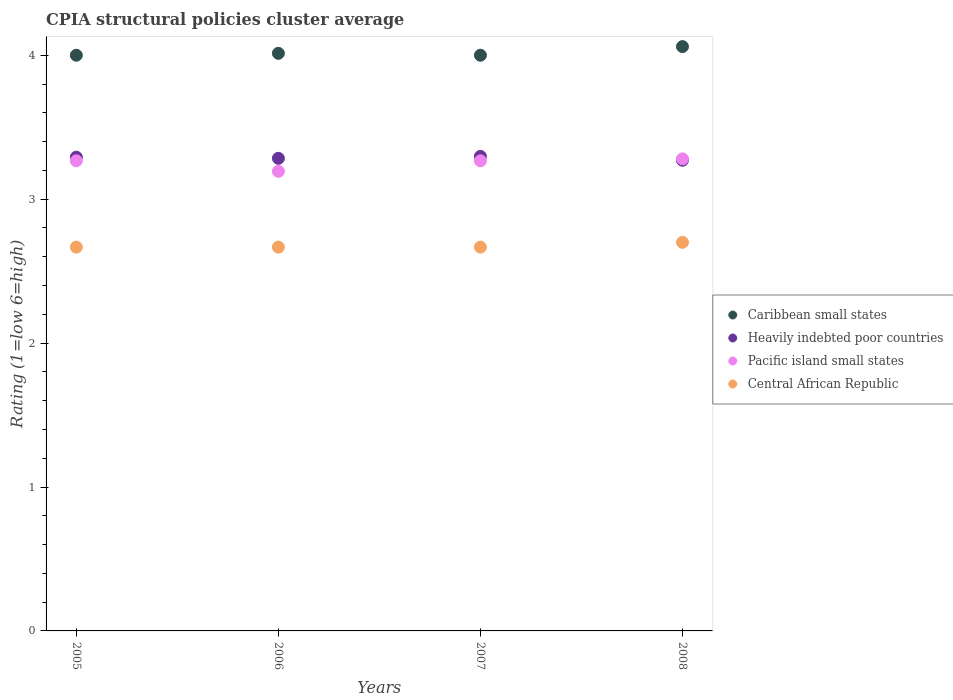How many different coloured dotlines are there?
Give a very brief answer. 4. What is the CPIA rating in Caribbean small states in 2008?
Provide a short and direct response. 4.06. Across all years, what is the maximum CPIA rating in Pacific island small states?
Make the answer very short. 3.28. Across all years, what is the minimum CPIA rating in Central African Republic?
Offer a terse response. 2.67. In which year was the CPIA rating in Central African Republic minimum?
Offer a very short reply. 2005. What is the total CPIA rating in Heavily indebted poor countries in the graph?
Your response must be concise. 13.14. What is the difference between the CPIA rating in Pacific island small states in 2006 and that in 2007?
Provide a short and direct response. -0.07. What is the difference between the CPIA rating in Heavily indebted poor countries in 2006 and the CPIA rating in Caribbean small states in 2008?
Offer a very short reply. -0.78. What is the average CPIA rating in Caribbean small states per year?
Offer a very short reply. 4.02. In the year 2005, what is the difference between the CPIA rating in Caribbean small states and CPIA rating in Pacific island small states?
Provide a succinct answer. 0.73. What is the ratio of the CPIA rating in Heavily indebted poor countries in 2006 to that in 2007?
Provide a short and direct response. 1. Is the difference between the CPIA rating in Caribbean small states in 2007 and 2008 greater than the difference between the CPIA rating in Pacific island small states in 2007 and 2008?
Ensure brevity in your answer.  No. What is the difference between the highest and the second highest CPIA rating in Central African Republic?
Keep it short and to the point. 0.03. What is the difference between the highest and the lowest CPIA rating in Heavily indebted poor countries?
Your response must be concise. 0.03. Is the CPIA rating in Central African Republic strictly greater than the CPIA rating in Heavily indebted poor countries over the years?
Keep it short and to the point. No. Is the CPIA rating in Heavily indebted poor countries strictly less than the CPIA rating in Central African Republic over the years?
Offer a very short reply. No. What is the difference between two consecutive major ticks on the Y-axis?
Offer a very short reply. 1. Does the graph contain any zero values?
Your answer should be compact. No. Does the graph contain grids?
Provide a short and direct response. No. How many legend labels are there?
Offer a terse response. 4. How are the legend labels stacked?
Provide a short and direct response. Vertical. What is the title of the graph?
Make the answer very short. CPIA structural policies cluster average. Does "Bulgaria" appear as one of the legend labels in the graph?
Give a very brief answer. No. What is the label or title of the X-axis?
Make the answer very short. Years. What is the label or title of the Y-axis?
Keep it short and to the point. Rating (1=low 6=high). What is the Rating (1=low 6=high) of Caribbean small states in 2005?
Ensure brevity in your answer.  4. What is the Rating (1=low 6=high) of Heavily indebted poor countries in 2005?
Keep it short and to the point. 3.29. What is the Rating (1=low 6=high) of Pacific island small states in 2005?
Keep it short and to the point. 3.27. What is the Rating (1=low 6=high) in Central African Republic in 2005?
Keep it short and to the point. 2.67. What is the Rating (1=low 6=high) of Caribbean small states in 2006?
Make the answer very short. 4.01. What is the Rating (1=low 6=high) in Heavily indebted poor countries in 2006?
Your response must be concise. 3.28. What is the Rating (1=low 6=high) in Pacific island small states in 2006?
Your response must be concise. 3.19. What is the Rating (1=low 6=high) of Central African Republic in 2006?
Your response must be concise. 2.67. What is the Rating (1=low 6=high) in Heavily indebted poor countries in 2007?
Keep it short and to the point. 3.3. What is the Rating (1=low 6=high) in Pacific island small states in 2007?
Your response must be concise. 3.27. What is the Rating (1=low 6=high) in Central African Republic in 2007?
Keep it short and to the point. 2.67. What is the Rating (1=low 6=high) in Caribbean small states in 2008?
Your response must be concise. 4.06. What is the Rating (1=low 6=high) of Heavily indebted poor countries in 2008?
Make the answer very short. 3.27. What is the Rating (1=low 6=high) in Pacific island small states in 2008?
Provide a short and direct response. 3.28. Across all years, what is the maximum Rating (1=low 6=high) of Caribbean small states?
Offer a terse response. 4.06. Across all years, what is the maximum Rating (1=low 6=high) of Heavily indebted poor countries?
Provide a succinct answer. 3.3. Across all years, what is the maximum Rating (1=low 6=high) in Pacific island small states?
Provide a succinct answer. 3.28. Across all years, what is the maximum Rating (1=low 6=high) in Central African Republic?
Keep it short and to the point. 2.7. Across all years, what is the minimum Rating (1=low 6=high) of Caribbean small states?
Offer a very short reply. 4. Across all years, what is the minimum Rating (1=low 6=high) of Heavily indebted poor countries?
Your response must be concise. 3.27. Across all years, what is the minimum Rating (1=low 6=high) of Pacific island small states?
Offer a terse response. 3.19. Across all years, what is the minimum Rating (1=low 6=high) in Central African Republic?
Provide a short and direct response. 2.67. What is the total Rating (1=low 6=high) of Caribbean small states in the graph?
Provide a succinct answer. 16.07. What is the total Rating (1=low 6=high) of Heavily indebted poor countries in the graph?
Make the answer very short. 13.14. What is the total Rating (1=low 6=high) of Pacific island small states in the graph?
Provide a succinct answer. 13.01. What is the total Rating (1=low 6=high) of Central African Republic in the graph?
Your response must be concise. 10.7. What is the difference between the Rating (1=low 6=high) in Caribbean small states in 2005 and that in 2006?
Keep it short and to the point. -0.01. What is the difference between the Rating (1=low 6=high) of Heavily indebted poor countries in 2005 and that in 2006?
Offer a very short reply. 0.01. What is the difference between the Rating (1=low 6=high) of Pacific island small states in 2005 and that in 2006?
Give a very brief answer. 0.07. What is the difference between the Rating (1=low 6=high) of Central African Republic in 2005 and that in 2006?
Ensure brevity in your answer.  0. What is the difference between the Rating (1=low 6=high) in Caribbean small states in 2005 and that in 2007?
Make the answer very short. 0. What is the difference between the Rating (1=low 6=high) of Heavily indebted poor countries in 2005 and that in 2007?
Give a very brief answer. -0.01. What is the difference between the Rating (1=low 6=high) of Pacific island small states in 2005 and that in 2007?
Make the answer very short. 0. What is the difference between the Rating (1=low 6=high) of Caribbean small states in 2005 and that in 2008?
Ensure brevity in your answer.  -0.06. What is the difference between the Rating (1=low 6=high) in Heavily indebted poor countries in 2005 and that in 2008?
Your answer should be very brief. 0.02. What is the difference between the Rating (1=low 6=high) of Pacific island small states in 2005 and that in 2008?
Give a very brief answer. -0.01. What is the difference between the Rating (1=low 6=high) of Central African Republic in 2005 and that in 2008?
Provide a short and direct response. -0.03. What is the difference between the Rating (1=low 6=high) in Caribbean small states in 2006 and that in 2007?
Provide a short and direct response. 0.01. What is the difference between the Rating (1=low 6=high) of Heavily indebted poor countries in 2006 and that in 2007?
Your response must be concise. -0.01. What is the difference between the Rating (1=low 6=high) in Pacific island small states in 2006 and that in 2007?
Your response must be concise. -0.07. What is the difference between the Rating (1=low 6=high) of Central African Republic in 2006 and that in 2007?
Make the answer very short. 0. What is the difference between the Rating (1=low 6=high) in Caribbean small states in 2006 and that in 2008?
Your response must be concise. -0.05. What is the difference between the Rating (1=low 6=high) in Heavily indebted poor countries in 2006 and that in 2008?
Offer a very short reply. 0.01. What is the difference between the Rating (1=low 6=high) of Pacific island small states in 2006 and that in 2008?
Your answer should be compact. -0.09. What is the difference between the Rating (1=low 6=high) of Central African Republic in 2006 and that in 2008?
Provide a succinct answer. -0.03. What is the difference between the Rating (1=low 6=high) of Caribbean small states in 2007 and that in 2008?
Give a very brief answer. -0.06. What is the difference between the Rating (1=low 6=high) of Heavily indebted poor countries in 2007 and that in 2008?
Keep it short and to the point. 0.03. What is the difference between the Rating (1=low 6=high) of Pacific island small states in 2007 and that in 2008?
Provide a short and direct response. -0.01. What is the difference between the Rating (1=low 6=high) in Central African Republic in 2007 and that in 2008?
Your answer should be very brief. -0.03. What is the difference between the Rating (1=low 6=high) of Caribbean small states in 2005 and the Rating (1=low 6=high) of Heavily indebted poor countries in 2006?
Your response must be concise. 0.72. What is the difference between the Rating (1=low 6=high) of Caribbean small states in 2005 and the Rating (1=low 6=high) of Pacific island small states in 2006?
Offer a very short reply. 0.81. What is the difference between the Rating (1=low 6=high) in Caribbean small states in 2005 and the Rating (1=low 6=high) in Central African Republic in 2006?
Offer a terse response. 1.33. What is the difference between the Rating (1=low 6=high) in Heavily indebted poor countries in 2005 and the Rating (1=low 6=high) in Pacific island small states in 2006?
Your response must be concise. 0.1. What is the difference between the Rating (1=low 6=high) in Caribbean small states in 2005 and the Rating (1=low 6=high) in Heavily indebted poor countries in 2007?
Offer a very short reply. 0.7. What is the difference between the Rating (1=low 6=high) in Caribbean small states in 2005 and the Rating (1=low 6=high) in Pacific island small states in 2007?
Make the answer very short. 0.73. What is the difference between the Rating (1=low 6=high) of Caribbean small states in 2005 and the Rating (1=low 6=high) of Central African Republic in 2007?
Offer a very short reply. 1.33. What is the difference between the Rating (1=low 6=high) of Heavily indebted poor countries in 2005 and the Rating (1=low 6=high) of Pacific island small states in 2007?
Your response must be concise. 0.03. What is the difference between the Rating (1=low 6=high) of Heavily indebted poor countries in 2005 and the Rating (1=low 6=high) of Central African Republic in 2007?
Your answer should be compact. 0.62. What is the difference between the Rating (1=low 6=high) in Pacific island small states in 2005 and the Rating (1=low 6=high) in Central African Republic in 2007?
Your answer should be very brief. 0.6. What is the difference between the Rating (1=low 6=high) of Caribbean small states in 2005 and the Rating (1=low 6=high) of Heavily indebted poor countries in 2008?
Offer a very short reply. 0.73. What is the difference between the Rating (1=low 6=high) of Caribbean small states in 2005 and the Rating (1=low 6=high) of Pacific island small states in 2008?
Your answer should be compact. 0.72. What is the difference between the Rating (1=low 6=high) of Caribbean small states in 2005 and the Rating (1=low 6=high) of Central African Republic in 2008?
Make the answer very short. 1.3. What is the difference between the Rating (1=low 6=high) in Heavily indebted poor countries in 2005 and the Rating (1=low 6=high) in Pacific island small states in 2008?
Ensure brevity in your answer.  0.01. What is the difference between the Rating (1=low 6=high) in Heavily indebted poor countries in 2005 and the Rating (1=low 6=high) in Central African Republic in 2008?
Make the answer very short. 0.59. What is the difference between the Rating (1=low 6=high) in Pacific island small states in 2005 and the Rating (1=low 6=high) in Central African Republic in 2008?
Provide a short and direct response. 0.57. What is the difference between the Rating (1=low 6=high) in Caribbean small states in 2006 and the Rating (1=low 6=high) in Heavily indebted poor countries in 2007?
Ensure brevity in your answer.  0.72. What is the difference between the Rating (1=low 6=high) of Caribbean small states in 2006 and the Rating (1=low 6=high) of Pacific island small states in 2007?
Provide a succinct answer. 0.75. What is the difference between the Rating (1=low 6=high) in Caribbean small states in 2006 and the Rating (1=low 6=high) in Central African Republic in 2007?
Your response must be concise. 1.35. What is the difference between the Rating (1=low 6=high) of Heavily indebted poor countries in 2006 and the Rating (1=low 6=high) of Pacific island small states in 2007?
Make the answer very short. 0.02. What is the difference between the Rating (1=low 6=high) of Heavily indebted poor countries in 2006 and the Rating (1=low 6=high) of Central African Republic in 2007?
Make the answer very short. 0.62. What is the difference between the Rating (1=low 6=high) in Pacific island small states in 2006 and the Rating (1=low 6=high) in Central African Republic in 2007?
Provide a succinct answer. 0.53. What is the difference between the Rating (1=low 6=high) in Caribbean small states in 2006 and the Rating (1=low 6=high) in Heavily indebted poor countries in 2008?
Make the answer very short. 0.74. What is the difference between the Rating (1=low 6=high) in Caribbean small states in 2006 and the Rating (1=low 6=high) in Pacific island small states in 2008?
Your answer should be compact. 0.73. What is the difference between the Rating (1=low 6=high) in Caribbean small states in 2006 and the Rating (1=low 6=high) in Central African Republic in 2008?
Keep it short and to the point. 1.31. What is the difference between the Rating (1=low 6=high) of Heavily indebted poor countries in 2006 and the Rating (1=low 6=high) of Pacific island small states in 2008?
Offer a terse response. 0. What is the difference between the Rating (1=low 6=high) in Heavily indebted poor countries in 2006 and the Rating (1=low 6=high) in Central African Republic in 2008?
Make the answer very short. 0.58. What is the difference between the Rating (1=low 6=high) in Pacific island small states in 2006 and the Rating (1=low 6=high) in Central African Republic in 2008?
Give a very brief answer. 0.49. What is the difference between the Rating (1=low 6=high) in Caribbean small states in 2007 and the Rating (1=low 6=high) in Heavily indebted poor countries in 2008?
Make the answer very short. 0.73. What is the difference between the Rating (1=low 6=high) of Caribbean small states in 2007 and the Rating (1=low 6=high) of Pacific island small states in 2008?
Make the answer very short. 0.72. What is the difference between the Rating (1=low 6=high) in Heavily indebted poor countries in 2007 and the Rating (1=low 6=high) in Pacific island small states in 2008?
Offer a very short reply. 0.02. What is the difference between the Rating (1=low 6=high) in Heavily indebted poor countries in 2007 and the Rating (1=low 6=high) in Central African Republic in 2008?
Your response must be concise. 0.6. What is the difference between the Rating (1=low 6=high) of Pacific island small states in 2007 and the Rating (1=low 6=high) of Central African Republic in 2008?
Your answer should be very brief. 0.57. What is the average Rating (1=low 6=high) in Caribbean small states per year?
Offer a terse response. 4.02. What is the average Rating (1=low 6=high) in Heavily indebted poor countries per year?
Offer a very short reply. 3.29. What is the average Rating (1=low 6=high) in Pacific island small states per year?
Your response must be concise. 3.25. What is the average Rating (1=low 6=high) of Central African Republic per year?
Provide a short and direct response. 2.67. In the year 2005, what is the difference between the Rating (1=low 6=high) of Caribbean small states and Rating (1=low 6=high) of Heavily indebted poor countries?
Give a very brief answer. 0.71. In the year 2005, what is the difference between the Rating (1=low 6=high) in Caribbean small states and Rating (1=low 6=high) in Pacific island small states?
Make the answer very short. 0.73. In the year 2005, what is the difference between the Rating (1=low 6=high) of Caribbean small states and Rating (1=low 6=high) of Central African Republic?
Ensure brevity in your answer.  1.33. In the year 2005, what is the difference between the Rating (1=low 6=high) in Heavily indebted poor countries and Rating (1=low 6=high) in Pacific island small states?
Provide a short and direct response. 0.03. In the year 2005, what is the difference between the Rating (1=low 6=high) in Pacific island small states and Rating (1=low 6=high) in Central African Republic?
Make the answer very short. 0.6. In the year 2006, what is the difference between the Rating (1=low 6=high) of Caribbean small states and Rating (1=low 6=high) of Heavily indebted poor countries?
Provide a short and direct response. 0.73. In the year 2006, what is the difference between the Rating (1=low 6=high) of Caribbean small states and Rating (1=low 6=high) of Pacific island small states?
Provide a short and direct response. 0.82. In the year 2006, what is the difference between the Rating (1=low 6=high) of Caribbean small states and Rating (1=low 6=high) of Central African Republic?
Your answer should be very brief. 1.35. In the year 2006, what is the difference between the Rating (1=low 6=high) in Heavily indebted poor countries and Rating (1=low 6=high) in Pacific island small states?
Ensure brevity in your answer.  0.09. In the year 2006, what is the difference between the Rating (1=low 6=high) of Heavily indebted poor countries and Rating (1=low 6=high) of Central African Republic?
Provide a short and direct response. 0.62. In the year 2006, what is the difference between the Rating (1=low 6=high) in Pacific island small states and Rating (1=low 6=high) in Central African Republic?
Your answer should be compact. 0.53. In the year 2007, what is the difference between the Rating (1=low 6=high) in Caribbean small states and Rating (1=low 6=high) in Heavily indebted poor countries?
Give a very brief answer. 0.7. In the year 2007, what is the difference between the Rating (1=low 6=high) of Caribbean small states and Rating (1=low 6=high) of Pacific island small states?
Offer a very short reply. 0.73. In the year 2007, what is the difference between the Rating (1=low 6=high) of Caribbean small states and Rating (1=low 6=high) of Central African Republic?
Offer a very short reply. 1.33. In the year 2007, what is the difference between the Rating (1=low 6=high) in Heavily indebted poor countries and Rating (1=low 6=high) in Pacific island small states?
Make the answer very short. 0.03. In the year 2007, what is the difference between the Rating (1=low 6=high) of Heavily indebted poor countries and Rating (1=low 6=high) of Central African Republic?
Keep it short and to the point. 0.63. In the year 2008, what is the difference between the Rating (1=low 6=high) in Caribbean small states and Rating (1=low 6=high) in Heavily indebted poor countries?
Offer a very short reply. 0.79. In the year 2008, what is the difference between the Rating (1=low 6=high) in Caribbean small states and Rating (1=low 6=high) in Pacific island small states?
Provide a short and direct response. 0.78. In the year 2008, what is the difference between the Rating (1=low 6=high) of Caribbean small states and Rating (1=low 6=high) of Central African Republic?
Offer a very short reply. 1.36. In the year 2008, what is the difference between the Rating (1=low 6=high) in Heavily indebted poor countries and Rating (1=low 6=high) in Pacific island small states?
Provide a succinct answer. -0.01. In the year 2008, what is the difference between the Rating (1=low 6=high) of Heavily indebted poor countries and Rating (1=low 6=high) of Central African Republic?
Provide a short and direct response. 0.57. In the year 2008, what is the difference between the Rating (1=low 6=high) of Pacific island small states and Rating (1=low 6=high) of Central African Republic?
Your response must be concise. 0.58. What is the ratio of the Rating (1=low 6=high) of Caribbean small states in 2005 to that in 2006?
Your answer should be compact. 1. What is the ratio of the Rating (1=low 6=high) of Central African Republic in 2005 to that in 2006?
Make the answer very short. 1. What is the ratio of the Rating (1=low 6=high) of Heavily indebted poor countries in 2005 to that in 2007?
Ensure brevity in your answer.  1. What is the ratio of the Rating (1=low 6=high) in Pacific island small states in 2005 to that in 2007?
Provide a short and direct response. 1. What is the ratio of the Rating (1=low 6=high) in Caribbean small states in 2005 to that in 2008?
Your answer should be compact. 0.99. What is the ratio of the Rating (1=low 6=high) of Heavily indebted poor countries in 2005 to that in 2008?
Your answer should be compact. 1.01. What is the ratio of the Rating (1=low 6=high) in Pacific island small states in 2005 to that in 2008?
Your answer should be very brief. 1. What is the ratio of the Rating (1=low 6=high) of Pacific island small states in 2006 to that in 2007?
Offer a terse response. 0.98. What is the ratio of the Rating (1=low 6=high) of Heavily indebted poor countries in 2006 to that in 2008?
Provide a succinct answer. 1. What is the ratio of the Rating (1=low 6=high) of Pacific island small states in 2006 to that in 2008?
Offer a very short reply. 0.97. What is the ratio of the Rating (1=low 6=high) in Central African Republic in 2006 to that in 2008?
Your answer should be compact. 0.99. What is the ratio of the Rating (1=low 6=high) of Caribbean small states in 2007 to that in 2008?
Offer a terse response. 0.99. What is the ratio of the Rating (1=low 6=high) in Heavily indebted poor countries in 2007 to that in 2008?
Your answer should be compact. 1.01. What is the ratio of the Rating (1=low 6=high) of Pacific island small states in 2007 to that in 2008?
Your response must be concise. 1. What is the difference between the highest and the second highest Rating (1=low 6=high) in Caribbean small states?
Make the answer very short. 0.05. What is the difference between the highest and the second highest Rating (1=low 6=high) of Heavily indebted poor countries?
Offer a very short reply. 0.01. What is the difference between the highest and the second highest Rating (1=low 6=high) of Pacific island small states?
Make the answer very short. 0.01. What is the difference between the highest and the lowest Rating (1=low 6=high) in Heavily indebted poor countries?
Make the answer very short. 0.03. What is the difference between the highest and the lowest Rating (1=low 6=high) in Pacific island small states?
Keep it short and to the point. 0.09. What is the difference between the highest and the lowest Rating (1=low 6=high) in Central African Republic?
Your answer should be compact. 0.03. 